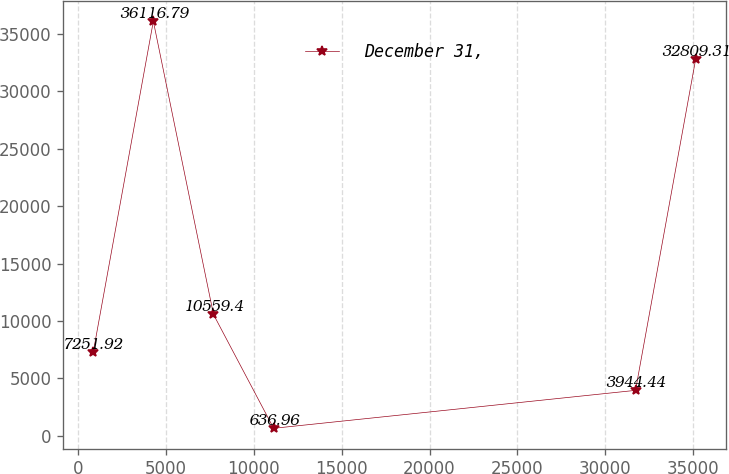Convert chart to OTSL. <chart><loc_0><loc_0><loc_500><loc_500><line_chart><ecel><fcel>December 31,<nl><fcel>849.1<fcel>7251.92<nl><fcel>4273.71<fcel>36116.8<nl><fcel>7698.32<fcel>10559.4<nl><fcel>11122.9<fcel>636.96<nl><fcel>31725.4<fcel>3944.44<nl><fcel>35150.1<fcel>32809.3<nl></chart> 